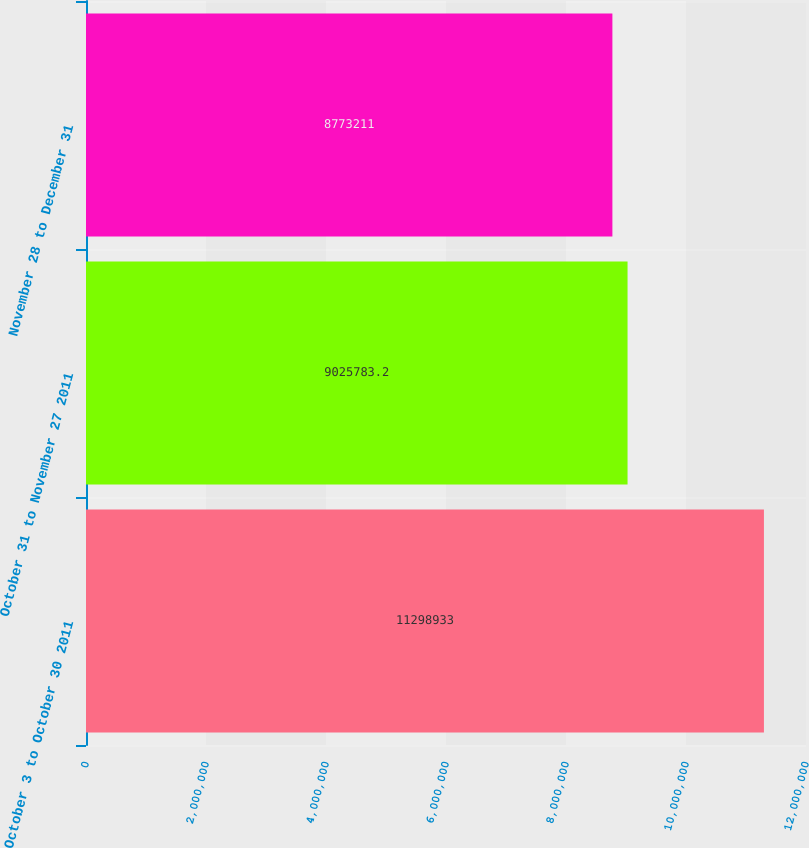Convert chart. <chart><loc_0><loc_0><loc_500><loc_500><bar_chart><fcel>October 3 to October 30 2011<fcel>October 31 to November 27 2011<fcel>November 28 to December 31<nl><fcel>1.12989e+07<fcel>9.02578e+06<fcel>8.77321e+06<nl></chart> 